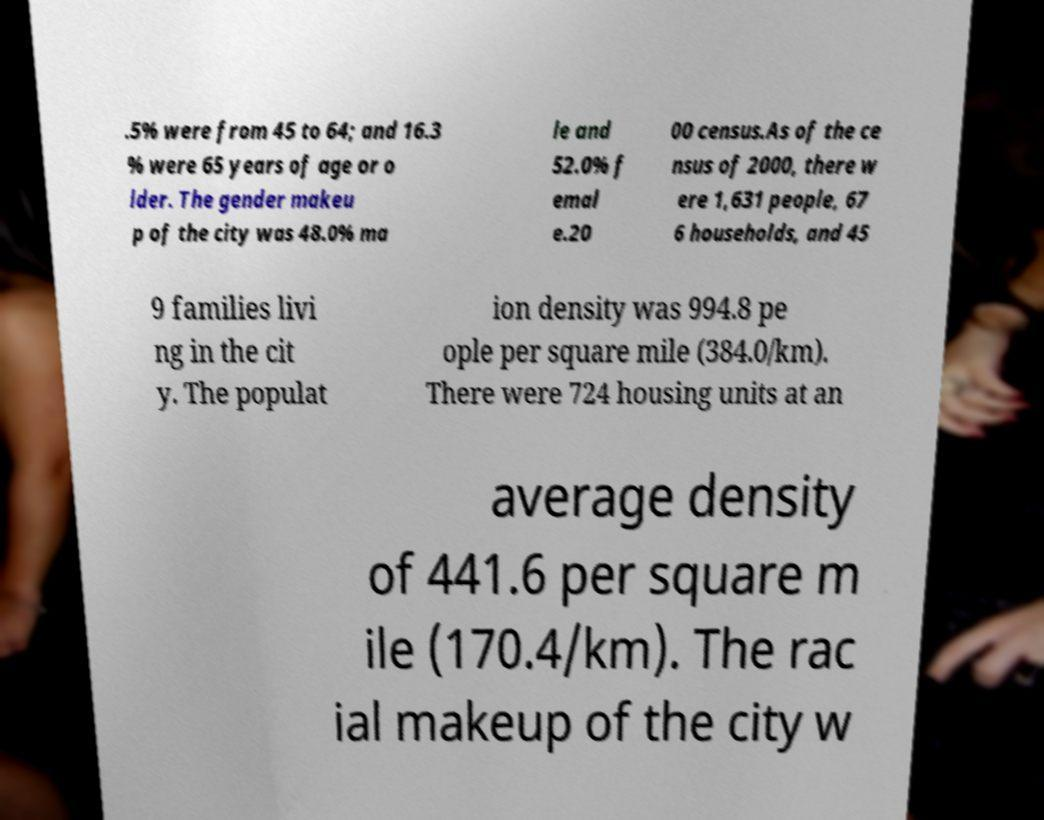Please identify and transcribe the text found in this image. .5% were from 45 to 64; and 16.3 % were 65 years of age or o lder. The gender makeu p of the city was 48.0% ma le and 52.0% f emal e.20 00 census.As of the ce nsus of 2000, there w ere 1,631 people, 67 6 households, and 45 9 families livi ng in the cit y. The populat ion density was 994.8 pe ople per square mile (384.0/km). There were 724 housing units at an average density of 441.6 per square m ile (170.4/km). The rac ial makeup of the city w 